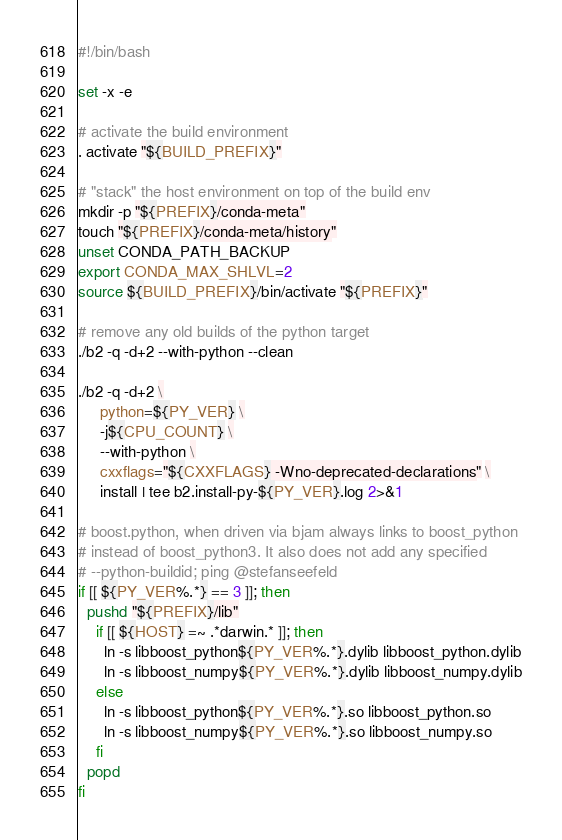<code> <loc_0><loc_0><loc_500><loc_500><_Bash_>#!/bin/bash

set -x -e

# activate the build environment
. activate "${BUILD_PREFIX}"

# "stack" the host environment on top of the build env
mkdir -p "${PREFIX}/conda-meta"
touch "${PREFIX}/conda-meta/history"
unset CONDA_PATH_BACKUP
export CONDA_MAX_SHLVL=2
source ${BUILD_PREFIX}/bin/activate "${PREFIX}"

# remove any old builds of the python target
./b2 -q -d+2 --with-python --clean

./b2 -q -d+2 \
     python=${PY_VER} \
     -j${CPU_COUNT} \
     --with-python \
     cxxflags="${CXXFLAGS} -Wno-deprecated-declarations" \
     install | tee b2.install-py-${PY_VER}.log 2>&1

# boost.python, when driven via bjam always links to boost_python
# instead of boost_python3. It also does not add any specified
# --python-buildid; ping @stefanseefeld
if [[ ${PY_VER%.*} == 3 ]]; then
  pushd "${PREFIX}/lib"
    if [[ ${HOST} =~ .*darwin.* ]]; then
      ln -s libboost_python${PY_VER%.*}.dylib libboost_python.dylib
      ln -s libboost_numpy${PY_VER%.*}.dylib libboost_numpy.dylib
    else
      ln -s libboost_python${PY_VER%.*}.so libboost_python.so
      ln -s libboost_numpy${PY_VER%.*}.so libboost_numpy.so
    fi
  popd
fi
</code> 